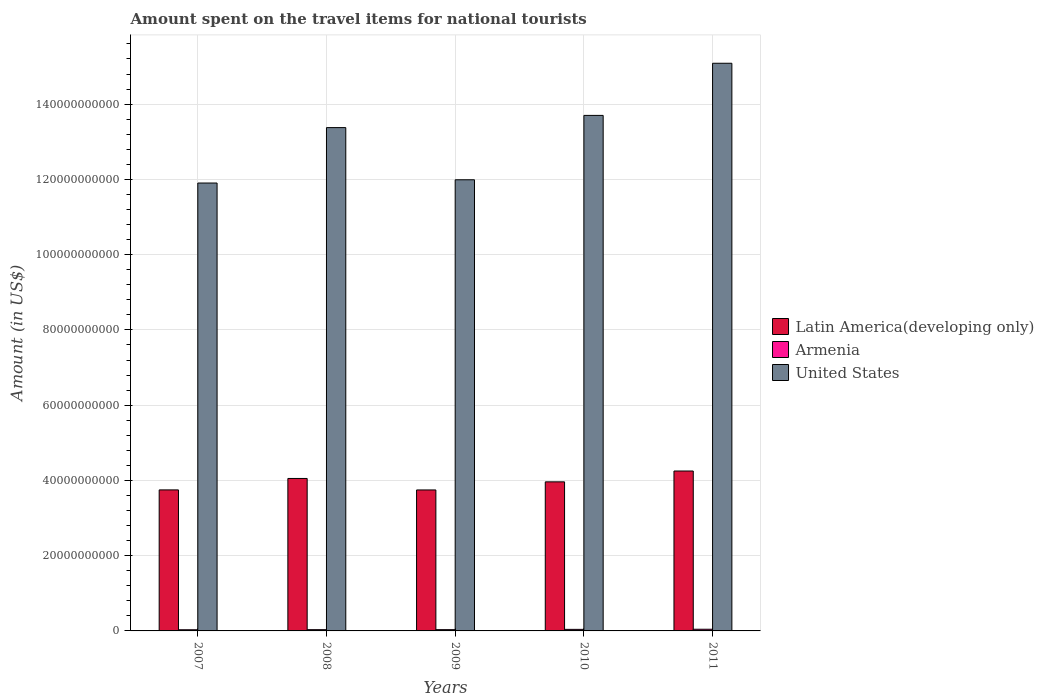How many different coloured bars are there?
Make the answer very short. 3. How many groups of bars are there?
Give a very brief answer. 5. Are the number of bars per tick equal to the number of legend labels?
Your answer should be compact. Yes. In how many cases, is the number of bars for a given year not equal to the number of legend labels?
Make the answer very short. 0. What is the amount spent on the travel items for national tourists in United States in 2007?
Your answer should be compact. 1.19e+11. Across all years, what is the maximum amount spent on the travel items for national tourists in United States?
Your answer should be compact. 1.51e+11. Across all years, what is the minimum amount spent on the travel items for national tourists in Latin America(developing only)?
Make the answer very short. 3.75e+1. In which year was the amount spent on the travel items for national tourists in Latin America(developing only) minimum?
Your response must be concise. 2009. What is the total amount spent on the travel items for national tourists in Armenia in the graph?
Make the answer very short. 1.84e+09. What is the difference between the amount spent on the travel items for national tourists in Latin America(developing only) in 2009 and that in 2010?
Give a very brief answer. -2.15e+09. What is the difference between the amount spent on the travel items for national tourists in Latin America(developing only) in 2008 and the amount spent on the travel items for national tourists in Armenia in 2010?
Offer a terse response. 4.01e+1. What is the average amount spent on the travel items for national tourists in Armenia per year?
Provide a short and direct response. 3.68e+08. In the year 2007, what is the difference between the amount spent on the travel items for national tourists in Armenia and amount spent on the travel items for national tourists in United States?
Make the answer very short. -1.19e+11. In how many years, is the amount spent on the travel items for national tourists in United States greater than 136000000000 US$?
Your answer should be very brief. 2. What is the ratio of the amount spent on the travel items for national tourists in Armenia in 2009 to that in 2011?
Offer a terse response. 0.75. Is the amount spent on the travel items for national tourists in Armenia in 2010 less than that in 2011?
Make the answer very short. Yes. What is the difference between the highest and the second highest amount spent on the travel items for national tourists in Latin America(developing only)?
Offer a very short reply. 1.98e+09. What is the difference between the highest and the lowest amount spent on the travel items for national tourists in United States?
Give a very brief answer. 3.18e+1. In how many years, is the amount spent on the travel items for national tourists in United States greater than the average amount spent on the travel items for national tourists in United States taken over all years?
Provide a short and direct response. 3. Is the sum of the amount spent on the travel items for national tourists in Latin America(developing only) in 2007 and 2009 greater than the maximum amount spent on the travel items for national tourists in United States across all years?
Offer a very short reply. No. What does the 3rd bar from the left in 2011 represents?
Give a very brief answer. United States. What does the 3rd bar from the right in 2011 represents?
Your response must be concise. Latin America(developing only). Is it the case that in every year, the sum of the amount spent on the travel items for national tourists in Armenia and amount spent on the travel items for national tourists in Latin America(developing only) is greater than the amount spent on the travel items for national tourists in United States?
Provide a succinct answer. No. Are all the bars in the graph horizontal?
Your response must be concise. No. How many years are there in the graph?
Give a very brief answer. 5. Are the values on the major ticks of Y-axis written in scientific E-notation?
Ensure brevity in your answer.  No. Does the graph contain any zero values?
Offer a terse response. No. Does the graph contain grids?
Keep it short and to the point. Yes. How many legend labels are there?
Your response must be concise. 3. What is the title of the graph?
Your answer should be compact. Amount spent on the travel items for national tourists. What is the label or title of the X-axis?
Your response must be concise. Years. What is the Amount (in US$) of Latin America(developing only) in 2007?
Offer a very short reply. 3.75e+1. What is the Amount (in US$) in Armenia in 2007?
Offer a terse response. 3.11e+08. What is the Amount (in US$) of United States in 2007?
Ensure brevity in your answer.  1.19e+11. What is the Amount (in US$) of Latin America(developing only) in 2008?
Your answer should be compact. 4.05e+1. What is the Amount (in US$) of Armenia in 2008?
Provide a succinct answer. 3.35e+08. What is the Amount (in US$) in United States in 2008?
Your answer should be very brief. 1.34e+11. What is the Amount (in US$) in Latin America(developing only) in 2009?
Ensure brevity in your answer.  3.75e+1. What is the Amount (in US$) in Armenia in 2009?
Keep it short and to the point. 3.37e+08. What is the Amount (in US$) in United States in 2009?
Make the answer very short. 1.20e+11. What is the Amount (in US$) of Latin America(developing only) in 2010?
Provide a short and direct response. 3.96e+1. What is the Amount (in US$) in Armenia in 2010?
Your answer should be very brief. 4.11e+08. What is the Amount (in US$) of United States in 2010?
Offer a terse response. 1.37e+11. What is the Amount (in US$) in Latin America(developing only) in 2011?
Make the answer very short. 4.25e+1. What is the Amount (in US$) in Armenia in 2011?
Your answer should be very brief. 4.48e+08. What is the Amount (in US$) in United States in 2011?
Offer a very short reply. 1.51e+11. Across all years, what is the maximum Amount (in US$) of Latin America(developing only)?
Ensure brevity in your answer.  4.25e+1. Across all years, what is the maximum Amount (in US$) of Armenia?
Make the answer very short. 4.48e+08. Across all years, what is the maximum Amount (in US$) of United States?
Your response must be concise. 1.51e+11. Across all years, what is the minimum Amount (in US$) of Latin America(developing only)?
Keep it short and to the point. 3.75e+1. Across all years, what is the minimum Amount (in US$) in Armenia?
Make the answer very short. 3.11e+08. Across all years, what is the minimum Amount (in US$) of United States?
Offer a terse response. 1.19e+11. What is the total Amount (in US$) of Latin America(developing only) in the graph?
Ensure brevity in your answer.  1.98e+11. What is the total Amount (in US$) in Armenia in the graph?
Give a very brief answer. 1.84e+09. What is the total Amount (in US$) in United States in the graph?
Keep it short and to the point. 6.61e+11. What is the difference between the Amount (in US$) of Latin America(developing only) in 2007 and that in 2008?
Provide a succinct answer. -3.04e+09. What is the difference between the Amount (in US$) of Armenia in 2007 and that in 2008?
Offer a very short reply. -2.40e+07. What is the difference between the Amount (in US$) in United States in 2007 and that in 2008?
Provide a short and direct response. -1.47e+1. What is the difference between the Amount (in US$) in Latin America(developing only) in 2007 and that in 2009?
Your answer should be compact. 1.40e+07. What is the difference between the Amount (in US$) in Armenia in 2007 and that in 2009?
Offer a very short reply. -2.60e+07. What is the difference between the Amount (in US$) in United States in 2007 and that in 2009?
Make the answer very short. -8.63e+08. What is the difference between the Amount (in US$) of Latin America(developing only) in 2007 and that in 2010?
Ensure brevity in your answer.  -2.14e+09. What is the difference between the Amount (in US$) of Armenia in 2007 and that in 2010?
Your answer should be very brief. -1.00e+08. What is the difference between the Amount (in US$) of United States in 2007 and that in 2010?
Keep it short and to the point. -1.80e+1. What is the difference between the Amount (in US$) in Latin America(developing only) in 2007 and that in 2011?
Ensure brevity in your answer.  -5.02e+09. What is the difference between the Amount (in US$) of Armenia in 2007 and that in 2011?
Make the answer very short. -1.37e+08. What is the difference between the Amount (in US$) of United States in 2007 and that in 2011?
Offer a terse response. -3.18e+1. What is the difference between the Amount (in US$) of Latin America(developing only) in 2008 and that in 2009?
Provide a short and direct response. 3.05e+09. What is the difference between the Amount (in US$) of United States in 2008 and that in 2009?
Make the answer very short. 1.39e+1. What is the difference between the Amount (in US$) in Latin America(developing only) in 2008 and that in 2010?
Give a very brief answer. 9.00e+08. What is the difference between the Amount (in US$) of Armenia in 2008 and that in 2010?
Ensure brevity in your answer.  -7.60e+07. What is the difference between the Amount (in US$) in United States in 2008 and that in 2010?
Your response must be concise. -3.24e+09. What is the difference between the Amount (in US$) in Latin America(developing only) in 2008 and that in 2011?
Keep it short and to the point. -1.98e+09. What is the difference between the Amount (in US$) of Armenia in 2008 and that in 2011?
Provide a short and direct response. -1.13e+08. What is the difference between the Amount (in US$) of United States in 2008 and that in 2011?
Your answer should be compact. -1.71e+1. What is the difference between the Amount (in US$) of Latin America(developing only) in 2009 and that in 2010?
Offer a very short reply. -2.15e+09. What is the difference between the Amount (in US$) of Armenia in 2009 and that in 2010?
Provide a succinct answer. -7.40e+07. What is the difference between the Amount (in US$) in United States in 2009 and that in 2010?
Provide a succinct answer. -1.71e+1. What is the difference between the Amount (in US$) in Latin America(developing only) in 2009 and that in 2011?
Give a very brief answer. -5.03e+09. What is the difference between the Amount (in US$) in Armenia in 2009 and that in 2011?
Your answer should be compact. -1.11e+08. What is the difference between the Amount (in US$) in United States in 2009 and that in 2011?
Your answer should be very brief. -3.10e+1. What is the difference between the Amount (in US$) of Latin America(developing only) in 2010 and that in 2011?
Give a very brief answer. -2.88e+09. What is the difference between the Amount (in US$) of Armenia in 2010 and that in 2011?
Provide a succinct answer. -3.70e+07. What is the difference between the Amount (in US$) in United States in 2010 and that in 2011?
Your answer should be very brief. -1.39e+1. What is the difference between the Amount (in US$) of Latin America(developing only) in 2007 and the Amount (in US$) of Armenia in 2008?
Your answer should be very brief. 3.71e+1. What is the difference between the Amount (in US$) of Latin America(developing only) in 2007 and the Amount (in US$) of United States in 2008?
Your response must be concise. -9.63e+1. What is the difference between the Amount (in US$) of Armenia in 2007 and the Amount (in US$) of United States in 2008?
Make the answer very short. -1.33e+11. What is the difference between the Amount (in US$) of Latin America(developing only) in 2007 and the Amount (in US$) of Armenia in 2009?
Provide a succinct answer. 3.71e+1. What is the difference between the Amount (in US$) in Latin America(developing only) in 2007 and the Amount (in US$) in United States in 2009?
Provide a short and direct response. -8.24e+1. What is the difference between the Amount (in US$) in Armenia in 2007 and the Amount (in US$) in United States in 2009?
Keep it short and to the point. -1.20e+11. What is the difference between the Amount (in US$) of Latin America(developing only) in 2007 and the Amount (in US$) of Armenia in 2010?
Your response must be concise. 3.71e+1. What is the difference between the Amount (in US$) in Latin America(developing only) in 2007 and the Amount (in US$) in United States in 2010?
Provide a short and direct response. -9.95e+1. What is the difference between the Amount (in US$) of Armenia in 2007 and the Amount (in US$) of United States in 2010?
Offer a terse response. -1.37e+11. What is the difference between the Amount (in US$) of Latin America(developing only) in 2007 and the Amount (in US$) of Armenia in 2011?
Ensure brevity in your answer.  3.70e+1. What is the difference between the Amount (in US$) in Latin America(developing only) in 2007 and the Amount (in US$) in United States in 2011?
Offer a terse response. -1.13e+11. What is the difference between the Amount (in US$) in Armenia in 2007 and the Amount (in US$) in United States in 2011?
Your response must be concise. -1.51e+11. What is the difference between the Amount (in US$) of Latin America(developing only) in 2008 and the Amount (in US$) of Armenia in 2009?
Offer a very short reply. 4.02e+1. What is the difference between the Amount (in US$) in Latin America(developing only) in 2008 and the Amount (in US$) in United States in 2009?
Offer a terse response. -7.94e+1. What is the difference between the Amount (in US$) of Armenia in 2008 and the Amount (in US$) of United States in 2009?
Your response must be concise. -1.20e+11. What is the difference between the Amount (in US$) in Latin America(developing only) in 2008 and the Amount (in US$) in Armenia in 2010?
Keep it short and to the point. 4.01e+1. What is the difference between the Amount (in US$) of Latin America(developing only) in 2008 and the Amount (in US$) of United States in 2010?
Provide a short and direct response. -9.65e+1. What is the difference between the Amount (in US$) of Armenia in 2008 and the Amount (in US$) of United States in 2010?
Offer a terse response. -1.37e+11. What is the difference between the Amount (in US$) in Latin America(developing only) in 2008 and the Amount (in US$) in Armenia in 2011?
Provide a succinct answer. 4.01e+1. What is the difference between the Amount (in US$) in Latin America(developing only) in 2008 and the Amount (in US$) in United States in 2011?
Offer a very short reply. -1.10e+11. What is the difference between the Amount (in US$) of Armenia in 2008 and the Amount (in US$) of United States in 2011?
Keep it short and to the point. -1.51e+11. What is the difference between the Amount (in US$) in Latin America(developing only) in 2009 and the Amount (in US$) in Armenia in 2010?
Your answer should be compact. 3.71e+1. What is the difference between the Amount (in US$) in Latin America(developing only) in 2009 and the Amount (in US$) in United States in 2010?
Offer a terse response. -9.95e+1. What is the difference between the Amount (in US$) in Armenia in 2009 and the Amount (in US$) in United States in 2010?
Make the answer very short. -1.37e+11. What is the difference between the Amount (in US$) in Latin America(developing only) in 2009 and the Amount (in US$) in Armenia in 2011?
Your response must be concise. 3.70e+1. What is the difference between the Amount (in US$) of Latin America(developing only) in 2009 and the Amount (in US$) of United States in 2011?
Make the answer very short. -1.13e+11. What is the difference between the Amount (in US$) of Armenia in 2009 and the Amount (in US$) of United States in 2011?
Make the answer very short. -1.51e+11. What is the difference between the Amount (in US$) in Latin America(developing only) in 2010 and the Amount (in US$) in Armenia in 2011?
Ensure brevity in your answer.  3.92e+1. What is the difference between the Amount (in US$) in Latin America(developing only) in 2010 and the Amount (in US$) in United States in 2011?
Offer a terse response. -1.11e+11. What is the difference between the Amount (in US$) in Armenia in 2010 and the Amount (in US$) in United States in 2011?
Provide a succinct answer. -1.50e+11. What is the average Amount (in US$) of Latin America(developing only) per year?
Offer a terse response. 3.95e+1. What is the average Amount (in US$) in Armenia per year?
Your answer should be very brief. 3.68e+08. What is the average Amount (in US$) in United States per year?
Your answer should be very brief. 1.32e+11. In the year 2007, what is the difference between the Amount (in US$) in Latin America(developing only) and Amount (in US$) in Armenia?
Your answer should be very brief. 3.72e+1. In the year 2007, what is the difference between the Amount (in US$) of Latin America(developing only) and Amount (in US$) of United States?
Provide a short and direct response. -8.16e+1. In the year 2007, what is the difference between the Amount (in US$) of Armenia and Amount (in US$) of United States?
Your answer should be very brief. -1.19e+11. In the year 2008, what is the difference between the Amount (in US$) in Latin America(developing only) and Amount (in US$) in Armenia?
Offer a terse response. 4.02e+1. In the year 2008, what is the difference between the Amount (in US$) in Latin America(developing only) and Amount (in US$) in United States?
Give a very brief answer. -9.32e+1. In the year 2008, what is the difference between the Amount (in US$) of Armenia and Amount (in US$) of United States?
Offer a terse response. -1.33e+11. In the year 2009, what is the difference between the Amount (in US$) of Latin America(developing only) and Amount (in US$) of Armenia?
Offer a very short reply. 3.71e+1. In the year 2009, what is the difference between the Amount (in US$) of Latin America(developing only) and Amount (in US$) of United States?
Your response must be concise. -8.24e+1. In the year 2009, what is the difference between the Amount (in US$) in Armenia and Amount (in US$) in United States?
Provide a short and direct response. -1.20e+11. In the year 2010, what is the difference between the Amount (in US$) in Latin America(developing only) and Amount (in US$) in Armenia?
Your response must be concise. 3.92e+1. In the year 2010, what is the difference between the Amount (in US$) of Latin America(developing only) and Amount (in US$) of United States?
Offer a terse response. -9.74e+1. In the year 2010, what is the difference between the Amount (in US$) of Armenia and Amount (in US$) of United States?
Provide a succinct answer. -1.37e+11. In the year 2011, what is the difference between the Amount (in US$) in Latin America(developing only) and Amount (in US$) in Armenia?
Provide a succinct answer. 4.21e+1. In the year 2011, what is the difference between the Amount (in US$) of Latin America(developing only) and Amount (in US$) of United States?
Give a very brief answer. -1.08e+11. In the year 2011, what is the difference between the Amount (in US$) of Armenia and Amount (in US$) of United States?
Keep it short and to the point. -1.50e+11. What is the ratio of the Amount (in US$) of Latin America(developing only) in 2007 to that in 2008?
Offer a terse response. 0.93. What is the ratio of the Amount (in US$) of Armenia in 2007 to that in 2008?
Give a very brief answer. 0.93. What is the ratio of the Amount (in US$) in United States in 2007 to that in 2008?
Provide a short and direct response. 0.89. What is the ratio of the Amount (in US$) of Latin America(developing only) in 2007 to that in 2009?
Provide a short and direct response. 1. What is the ratio of the Amount (in US$) in Armenia in 2007 to that in 2009?
Your answer should be compact. 0.92. What is the ratio of the Amount (in US$) in United States in 2007 to that in 2009?
Your answer should be compact. 0.99. What is the ratio of the Amount (in US$) of Latin America(developing only) in 2007 to that in 2010?
Provide a short and direct response. 0.95. What is the ratio of the Amount (in US$) of Armenia in 2007 to that in 2010?
Make the answer very short. 0.76. What is the ratio of the Amount (in US$) of United States in 2007 to that in 2010?
Your response must be concise. 0.87. What is the ratio of the Amount (in US$) of Latin America(developing only) in 2007 to that in 2011?
Make the answer very short. 0.88. What is the ratio of the Amount (in US$) in Armenia in 2007 to that in 2011?
Make the answer very short. 0.69. What is the ratio of the Amount (in US$) in United States in 2007 to that in 2011?
Provide a succinct answer. 0.79. What is the ratio of the Amount (in US$) in Latin America(developing only) in 2008 to that in 2009?
Give a very brief answer. 1.08. What is the ratio of the Amount (in US$) in Armenia in 2008 to that in 2009?
Offer a terse response. 0.99. What is the ratio of the Amount (in US$) of United States in 2008 to that in 2009?
Provide a short and direct response. 1.12. What is the ratio of the Amount (in US$) in Latin America(developing only) in 2008 to that in 2010?
Your response must be concise. 1.02. What is the ratio of the Amount (in US$) of Armenia in 2008 to that in 2010?
Give a very brief answer. 0.82. What is the ratio of the Amount (in US$) in United States in 2008 to that in 2010?
Your response must be concise. 0.98. What is the ratio of the Amount (in US$) in Latin America(developing only) in 2008 to that in 2011?
Give a very brief answer. 0.95. What is the ratio of the Amount (in US$) of Armenia in 2008 to that in 2011?
Keep it short and to the point. 0.75. What is the ratio of the Amount (in US$) of United States in 2008 to that in 2011?
Provide a succinct answer. 0.89. What is the ratio of the Amount (in US$) in Latin America(developing only) in 2009 to that in 2010?
Your answer should be very brief. 0.95. What is the ratio of the Amount (in US$) of Armenia in 2009 to that in 2010?
Offer a very short reply. 0.82. What is the ratio of the Amount (in US$) in United States in 2009 to that in 2010?
Keep it short and to the point. 0.88. What is the ratio of the Amount (in US$) in Latin America(developing only) in 2009 to that in 2011?
Provide a succinct answer. 0.88. What is the ratio of the Amount (in US$) in Armenia in 2009 to that in 2011?
Give a very brief answer. 0.75. What is the ratio of the Amount (in US$) of United States in 2009 to that in 2011?
Provide a succinct answer. 0.79. What is the ratio of the Amount (in US$) of Latin America(developing only) in 2010 to that in 2011?
Your answer should be very brief. 0.93. What is the ratio of the Amount (in US$) of Armenia in 2010 to that in 2011?
Your answer should be compact. 0.92. What is the ratio of the Amount (in US$) of United States in 2010 to that in 2011?
Provide a short and direct response. 0.91. What is the difference between the highest and the second highest Amount (in US$) of Latin America(developing only)?
Keep it short and to the point. 1.98e+09. What is the difference between the highest and the second highest Amount (in US$) of Armenia?
Offer a terse response. 3.70e+07. What is the difference between the highest and the second highest Amount (in US$) in United States?
Your response must be concise. 1.39e+1. What is the difference between the highest and the lowest Amount (in US$) of Latin America(developing only)?
Make the answer very short. 5.03e+09. What is the difference between the highest and the lowest Amount (in US$) in Armenia?
Offer a very short reply. 1.37e+08. What is the difference between the highest and the lowest Amount (in US$) in United States?
Provide a short and direct response. 3.18e+1. 